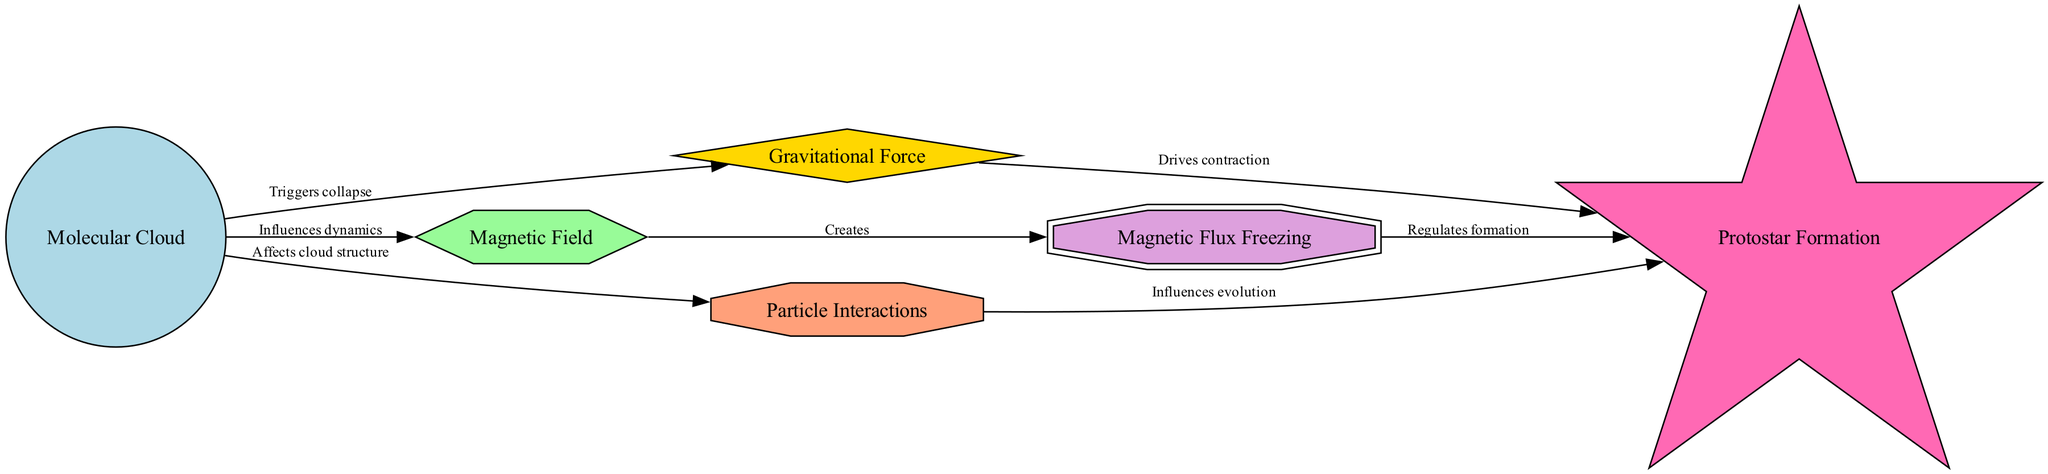What is the first node in the diagram? The first node in the diagram is identified as "Molecular Cloud," which serves as the starting point for the processes depicted.
Answer: Molecular Cloud How many nodes are present in the diagram? The diagram contains a total of six nodes: Molecular Cloud, Gravitational Force, Magnetic Field, Particle Interactions, Protostar Formation, and Magnetic Flux Freezing.
Answer: 6 What directs the contraction towards protostar formation? The Gravitational Force node, which is indicated in the edges as driving the contraction towards the Protostar node.
Answer: Gravitational Force Which node is influenced by the magnetic field? The Particle Interactions node is influenced by the Magnetic Field, as shown by the edge connecting them that highlights the effect on the cloud structure.
Answer: Particle Interactions What does the Magnetic Flux Freezing node do in the context of protostar formation? The Magnetic Flux Freezing node regulates the formation of the Protostar, as evident from the directed edge connecting these two nodes.
Answer: Regulates formation How do particle interactions affect protostar development? Particle interactions influence the evolution of the Protostar, as indicated by the edge between the Particle Interactions and Protostar nodes that highlights their relationship.
Answer: Influences evolution What relationship does the molecular cloud have with the gravitational force? The relationship is defined as the "Triggers collapse," which shows that the molecular cloud triggers the gravitational force to initiate the collapse process.
Answer: Triggers collapse What creates magnetic flux according to the diagram? The Magnetic Field node creates the Magnetic Flux Freezing, as depicted by the directed edge, indicating a direct relationship between these two nodes.
Answer: Creates Which processes affect the structure of molecular clouds? The effects on the structure of molecular clouds come from interactions with the Gravitational Force, Magnetic Field, and Particle Interactions nodes, which all have edges pointing from the Molecular Cloud node.
Answer: Gravity, Magnetic Field, Particle Interactions 